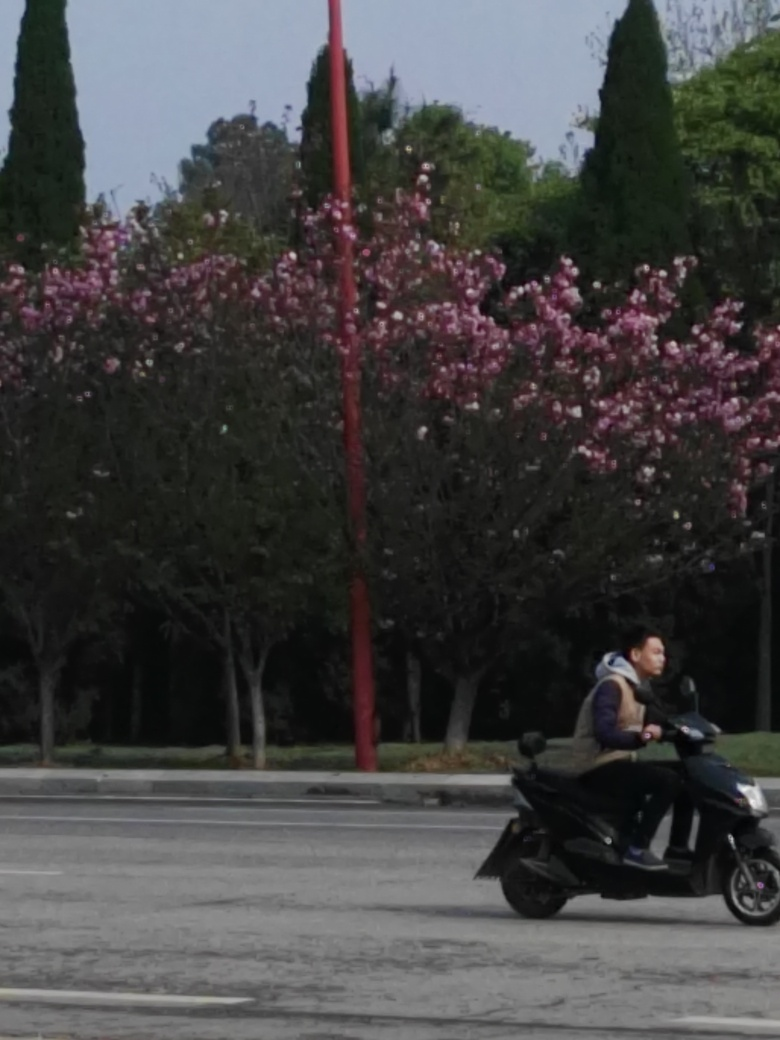Can you describe the setting of this image? Certainly! The image depicts an outdoor urban scene. There is a road in the foreground with visible traffic lanes, and the background features a variety of trees, including some with pink blossoms that suggest it may be spring. A red pole stands out near the center, contrasting with the natural colors. A person riding a motor scooter is seen crossing the street, adding a dynamic element to the otherwise still environment. 